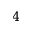Convert formula to latex. <formula><loc_0><loc_0><loc_500><loc_500>4</formula> 